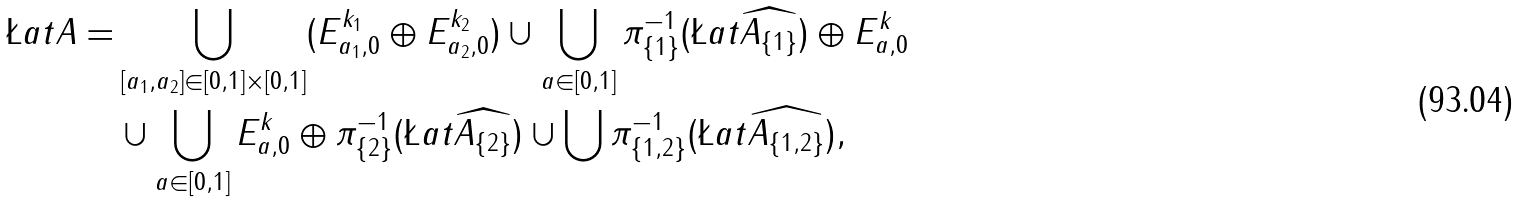<formula> <loc_0><loc_0><loc_500><loc_500>\L a t A = & \bigcup _ { [ a _ { 1 } , a _ { 2 } ] \in [ 0 , 1 ] \times [ 0 , 1 ] } ( E _ { a _ { 1 } , 0 } ^ { k _ { 1 } } \oplus E _ { a _ { 2 } , 0 } ^ { k _ { 2 } } ) \cup \bigcup _ { a \in [ 0 , 1 ] } \pi _ { \{ 1 \} } ^ { - 1 } ( \L a t \widehat { A _ { \{ 1 \} } } ) \oplus E _ { a , 0 } ^ { k } \\ & \cup \bigcup _ { a \in [ 0 , 1 ] } E _ { a , 0 } ^ { k } \oplus \pi _ { \{ 2 \} } ^ { - 1 } ( \L a t \widehat { A _ { \{ 2 \} } } ) \cup \bigcup \pi _ { \{ 1 , 2 \} } ^ { - 1 } ( \L a t \widehat { A _ { \{ 1 , 2 \} } } ) ,</formula> 